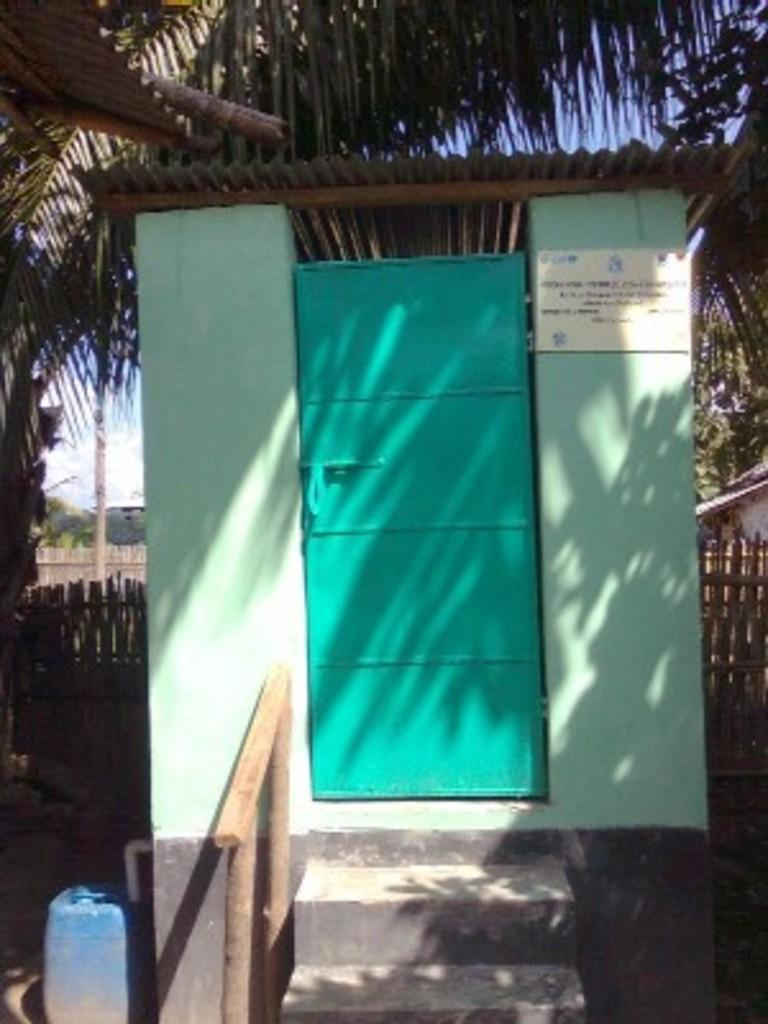What is the main subject of the image? The main subject of the image is a room. Can you describe the background of the image? Trees are visible behind the room. How many squirrels are climbing on the cord in the image? There is no cord or squirrel present in the image. 